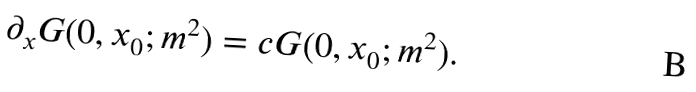Convert formula to latex. <formula><loc_0><loc_0><loc_500><loc_500>\partial _ { x } G ( 0 , x _ { 0 } ; m ^ { 2 } ) = c G ( 0 , x _ { 0 } ; m ^ { 2 } ) .</formula> 